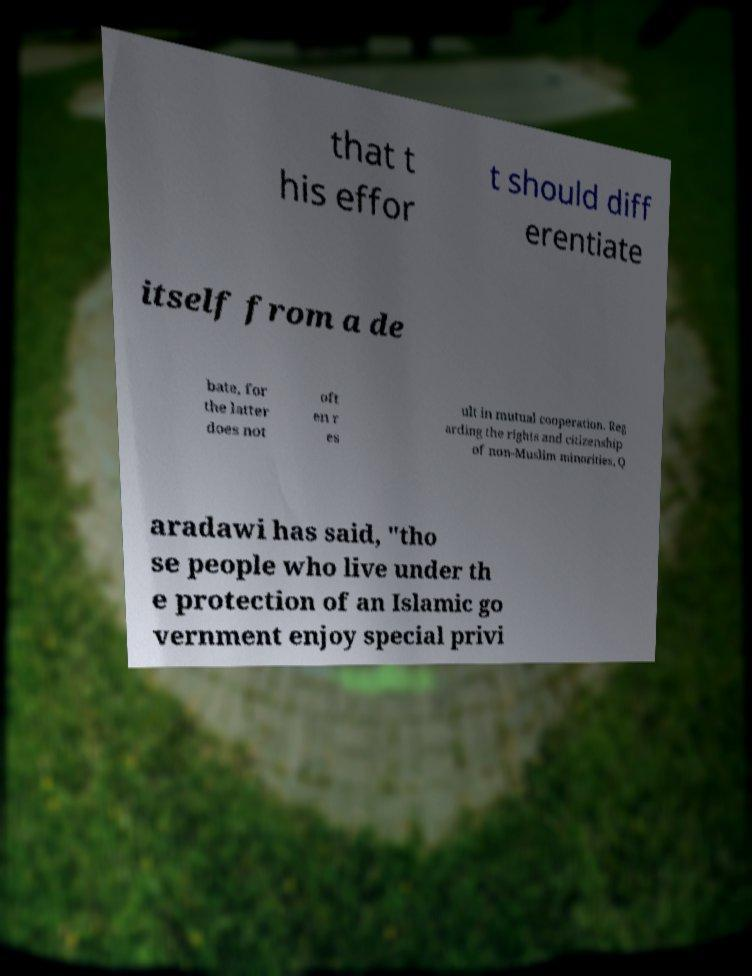Can you accurately transcribe the text from the provided image for me? that t his effor t should diff erentiate itself from a de bate, for the latter does not oft en r es ult in mutual cooperation. Reg arding the rights and citizenship of non-Muslim minorities, Q aradawi has said, "tho se people who live under th e protection of an Islamic go vernment enjoy special privi 